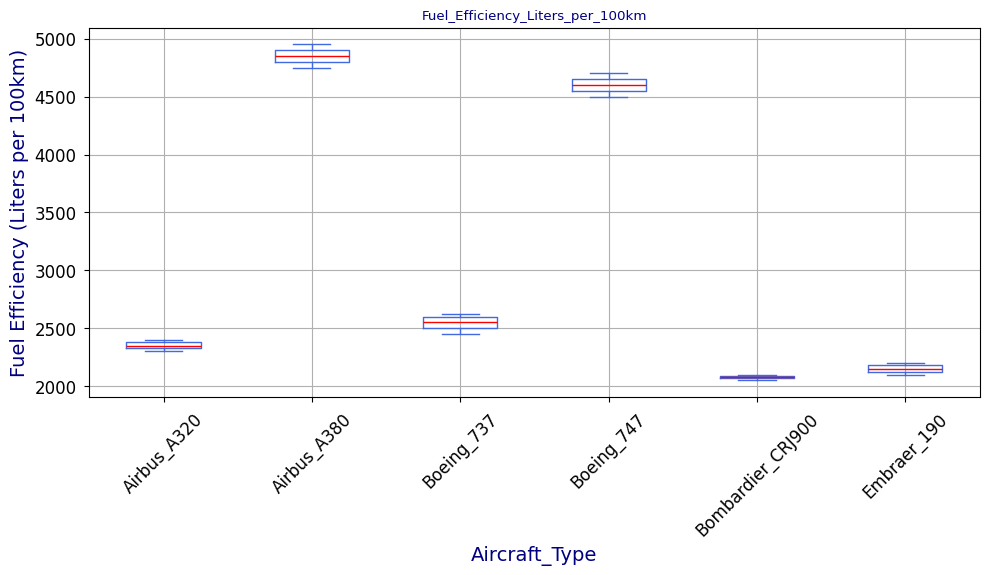Which aircraft type has the lowest median fuel efficiency? Look at the median lines (in red) within each box. The lowest red line (median) appears for the Bombardier CRJ900.
Answer: Bombardier CRJ900 Which aircraft type has the highest median fuel efficiency? Look at the median lines (in red) within each box. The highest red line (median) appears for the Airbus A380.
Answer: Airbus A380 What's the range of fuel efficiency for the Boeing 737? Identify the minimum and maximum values for Boeing 737 by locating the bottom and top whiskers of the box plot for this group. Min: 2450, Max: 2620. Range = 2620 - 2450 = 170.
Answer: 170 Compare the interquartile range (IQR) of Boeing 747 and Airbus A320. Which one is larger? IQR is the height of the box (Q3 - Q1) in each group. Compare the heights visually. The Boeing 747 appears to have a larger IQR than the Airbus A320.
Answer: Boeing 747 Which aircraft type shows the most variability in its fuel efficiency values? Variability can be inferred from the overall height of the whiskers and the range in each box plot. The Airbus A380 shows the highest range, indicating the most variability.
Answer: Airbus A380 How does the median fuel efficiency of the Embraer 190 compare to that of the Airbus A320? Compare the red median lines in the boxes for Embraer 190 and Airbus A320. The Embraer 190's median is lower than the Airbus A320's median.
Answer: Lower Which aircraft types have outliers in their data, and what color are those outliers? Outliers are marked by different symbols (orange circles) outside the whiskers. Check each box plot for these symbols. Both Boeing 737 and Airbus A320 have outliers, marked in orange.
Answer: Boeing 737, Airbus A320 What's the difference between the maximum fuel efficiencies of Embraer 190 and Airbus A380? Locate the top whiskers for Embraer 190 (2180) and Airbus A380 (4950). Subtract the former from the latter. Difference = 4950 - 2180 = 2770.
Answer: 2770 Is there a noticeable trend in fuel efficiency between smaller and larger aircraft types? Generally, larger aircraft types like the Airbus A380 and Boeing 747 have higher fuel efficiency values (more liters per 100km), while smaller aircraft like the Bombardier CRJ900 and Embraer 190 have lower values. This trend can be derived from comparing the positions of box plots for large and small aircraft.
Answer: Yes Which aircraft type has the smallest interquartile range (IQR), and what does it indicate? The smallest IQR can be identified by the narrowest box. The Bombardier CRJ900 has the smallest IQR, indicating less variability and more consistency in its fuel efficiency values.
Answer: Bombardier CRJ900 